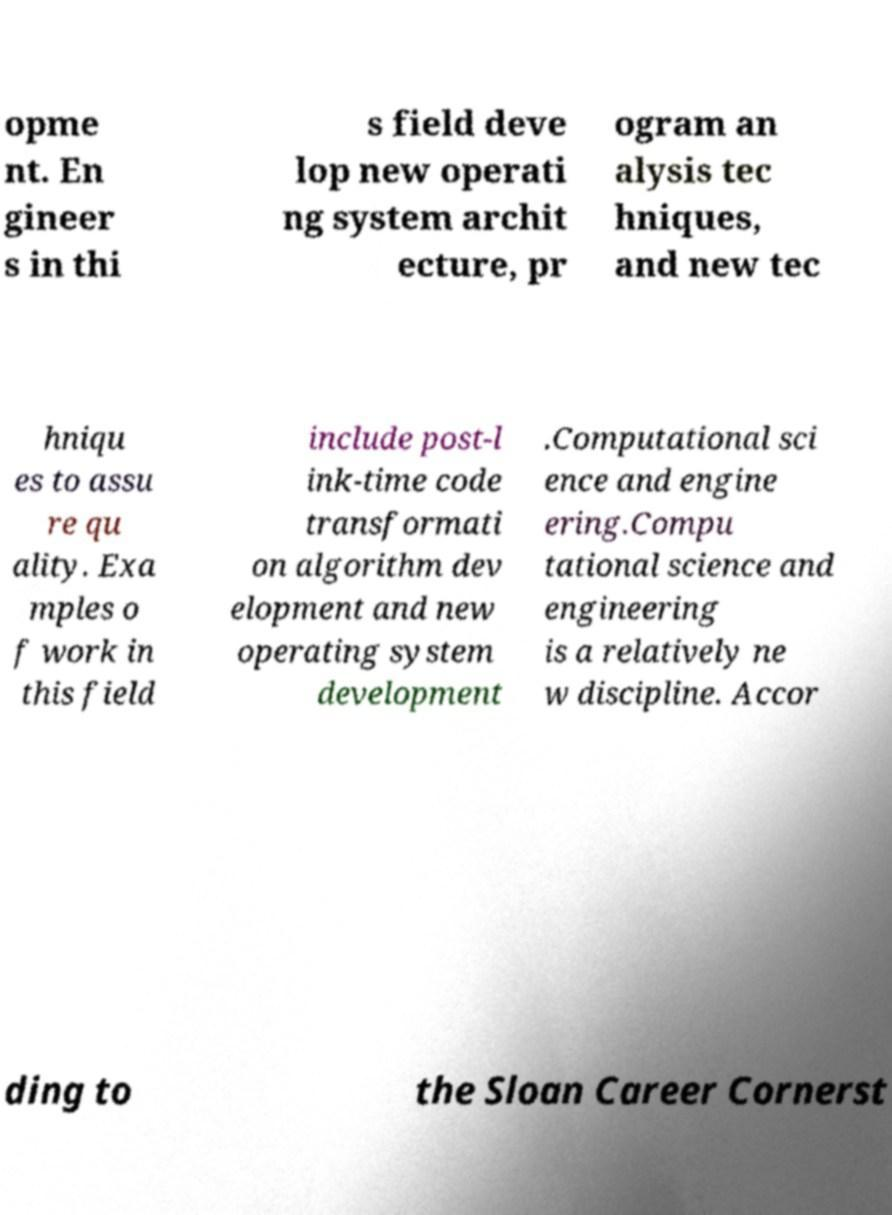Can you accurately transcribe the text from the provided image for me? opme nt. En gineer s in thi s field deve lop new operati ng system archit ecture, pr ogram an alysis tec hniques, and new tec hniqu es to assu re qu ality. Exa mples o f work in this field include post-l ink-time code transformati on algorithm dev elopment and new operating system development .Computational sci ence and engine ering.Compu tational science and engineering is a relatively ne w discipline. Accor ding to the Sloan Career Cornerst 